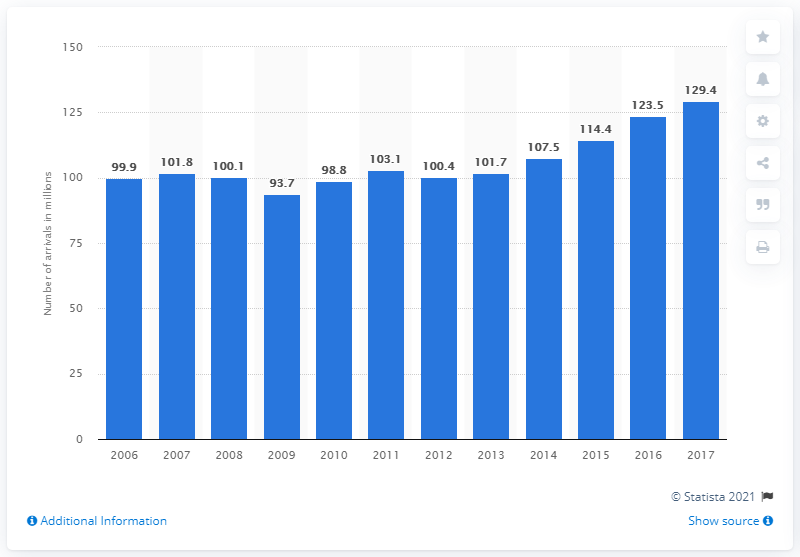Specify some key components in this picture. In 2017, a total of 129,400 tourists arrived at accommodation establishments in Spain. 